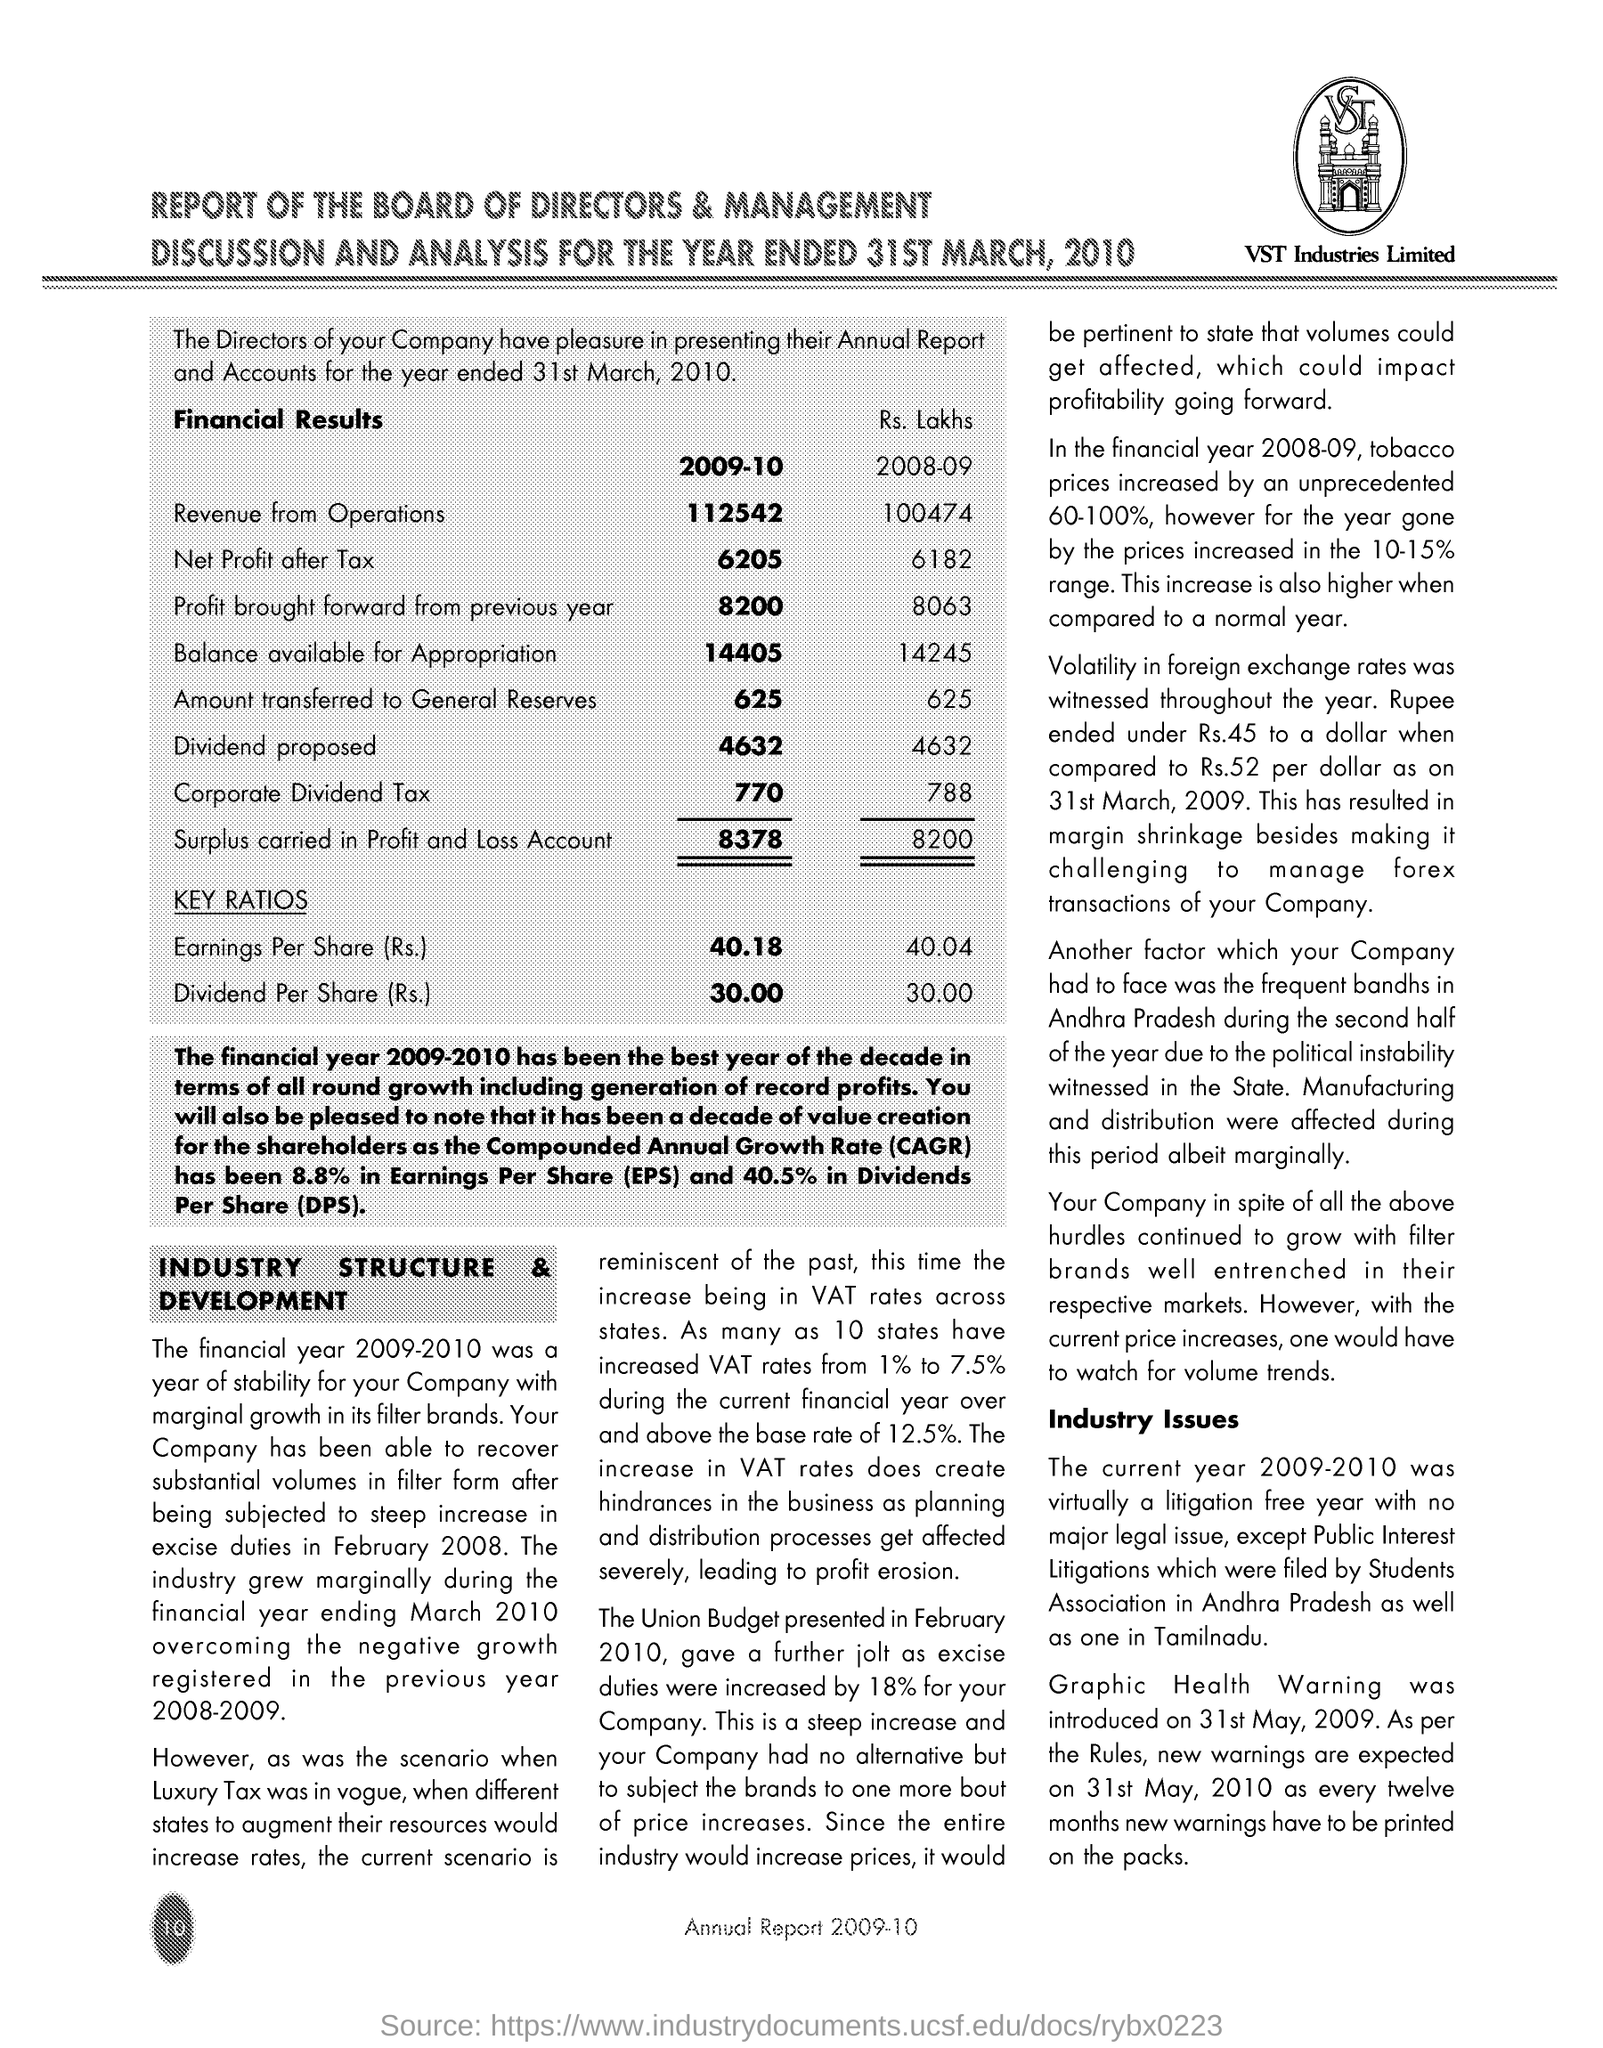Point out several critical features in this image. DPS stands for dividends per share, which refers to the amount of cash or other compensation paid to each shareholder for each share of stock owned. Earnings per share (EPS) refers to the amount of earnings that are attributed to each outstanding share of a company's stock. In 2009-10, a total of 625 units of funds were transferred to the general reserves. The company named VST Industries Limited. The full form of CAGR is Compounded Annual Growth Rate. This refers to the rate at which the value of a particular variable, such as a stock price or revenue, grows each year, taking into account any previous growth. 